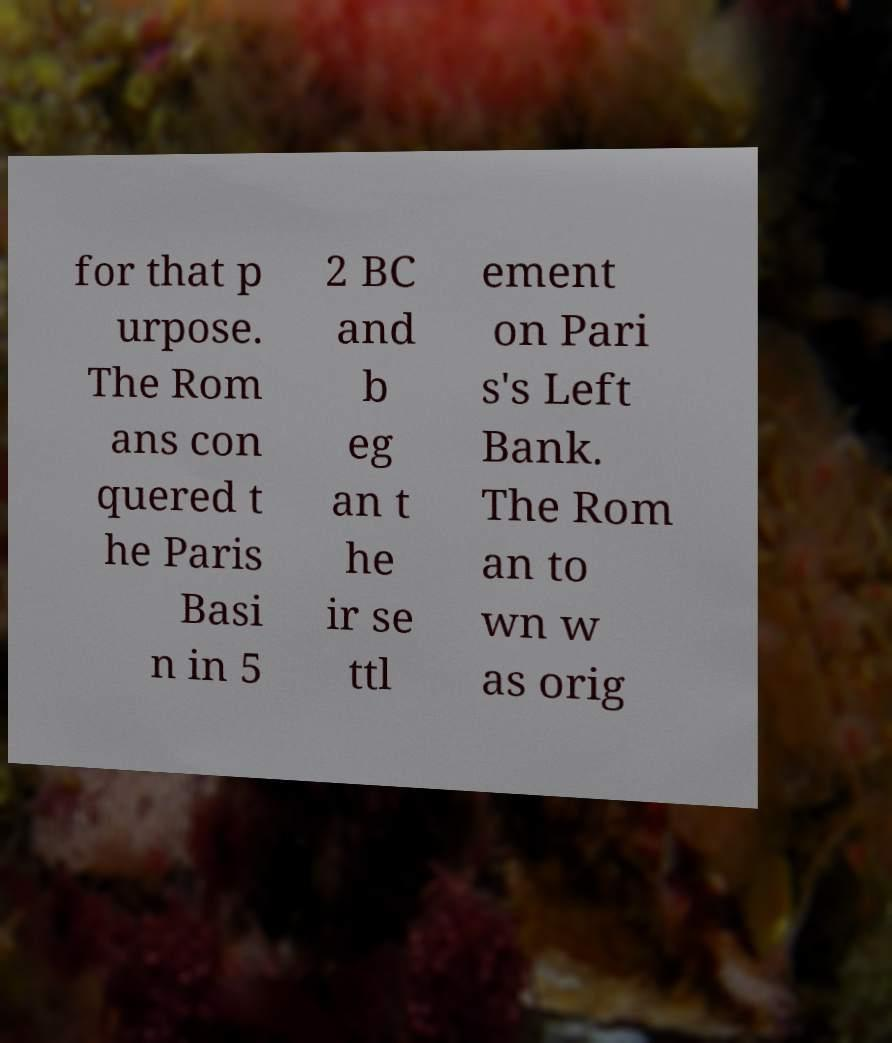Could you assist in decoding the text presented in this image and type it out clearly? for that p urpose. The Rom ans con quered t he Paris Basi n in 5 2 BC and b eg an t he ir se ttl ement on Pari s's Left Bank. The Rom an to wn w as orig 